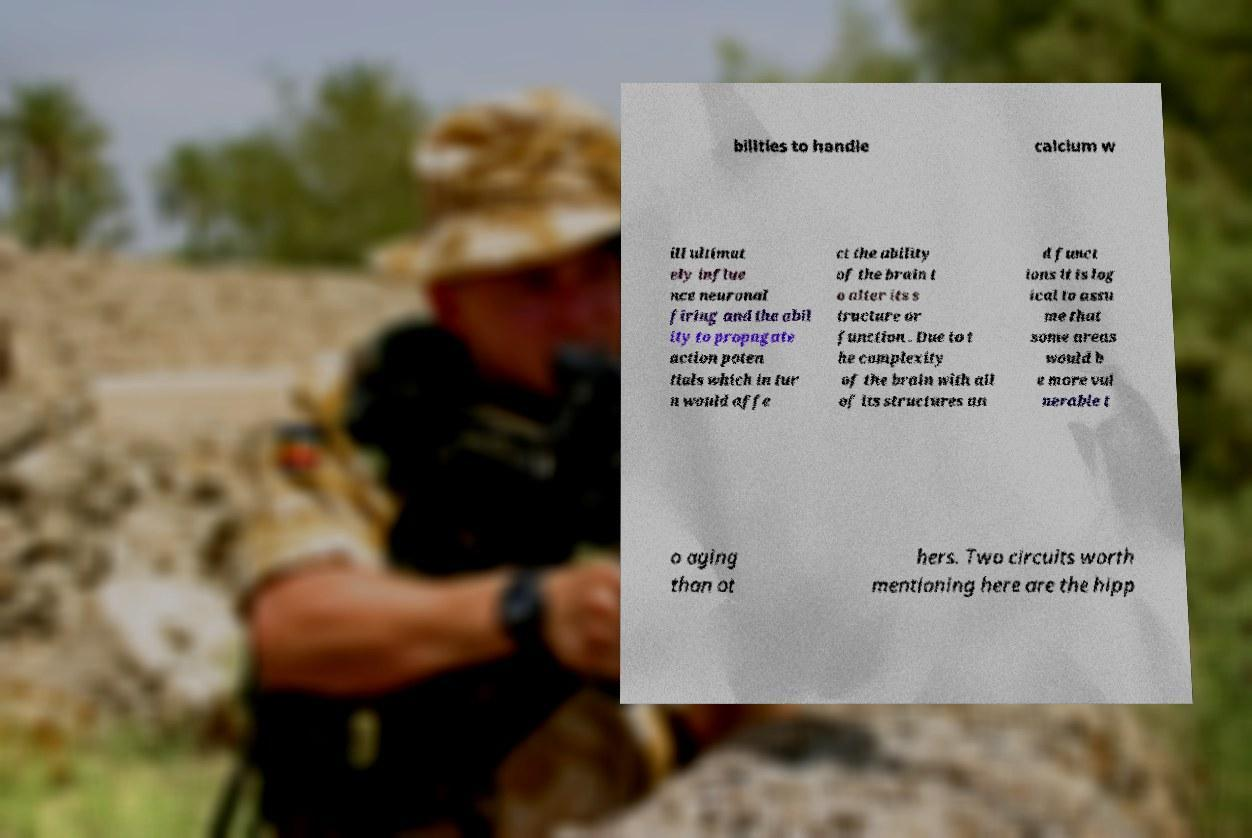Can you accurately transcribe the text from the provided image for me? bilities to handle calcium w ill ultimat ely influe nce neuronal firing and the abil ity to propagate action poten tials which in tur n would affe ct the ability of the brain t o alter its s tructure or function . Due to t he complexity of the brain with all of its structures an d funct ions it is log ical to assu me that some areas would b e more vul nerable t o aging than ot hers. Two circuits worth mentioning here are the hipp 